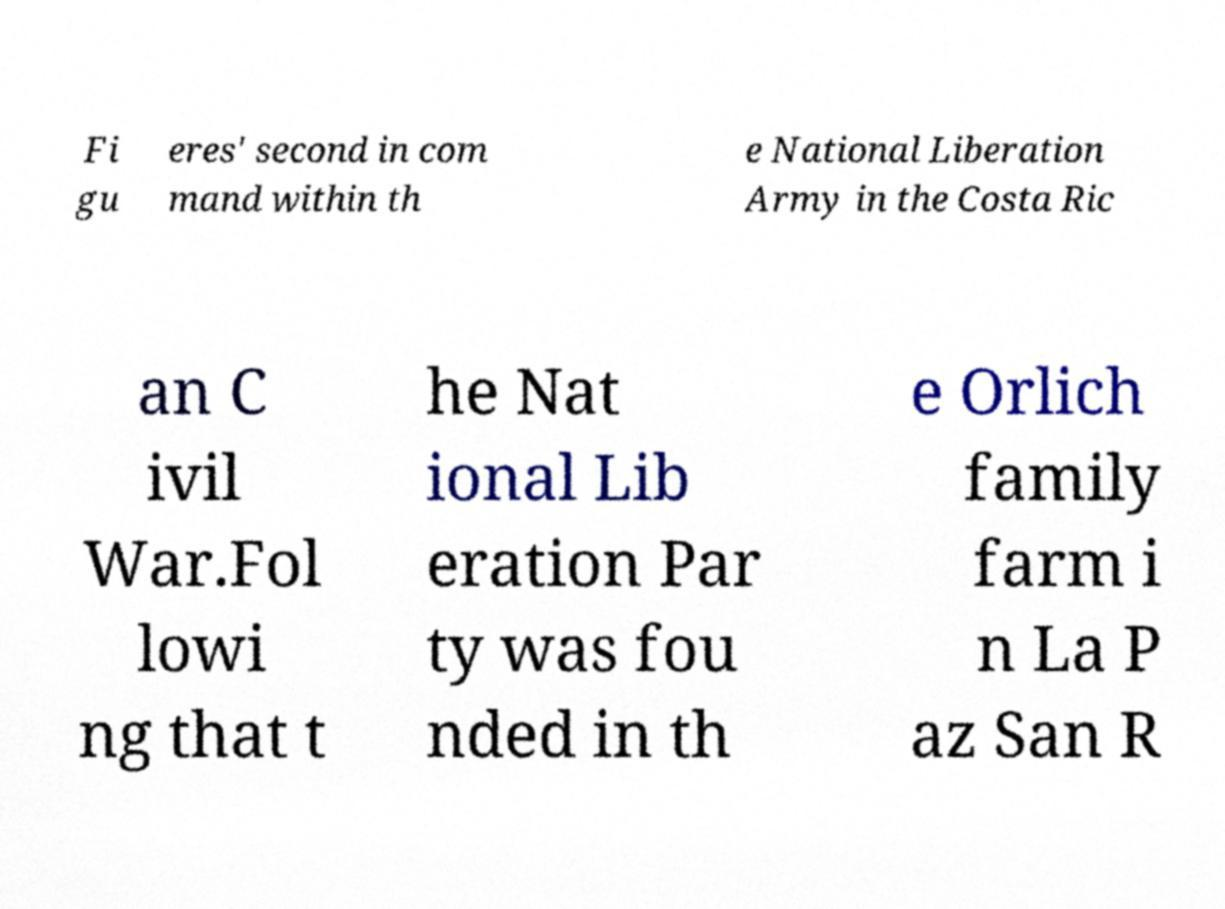Could you assist in decoding the text presented in this image and type it out clearly? Fi gu eres' second in com mand within th e National Liberation Army in the Costa Ric an C ivil War.Fol lowi ng that t he Nat ional Lib eration Par ty was fou nded in th e Orlich family farm i n La P az San R 